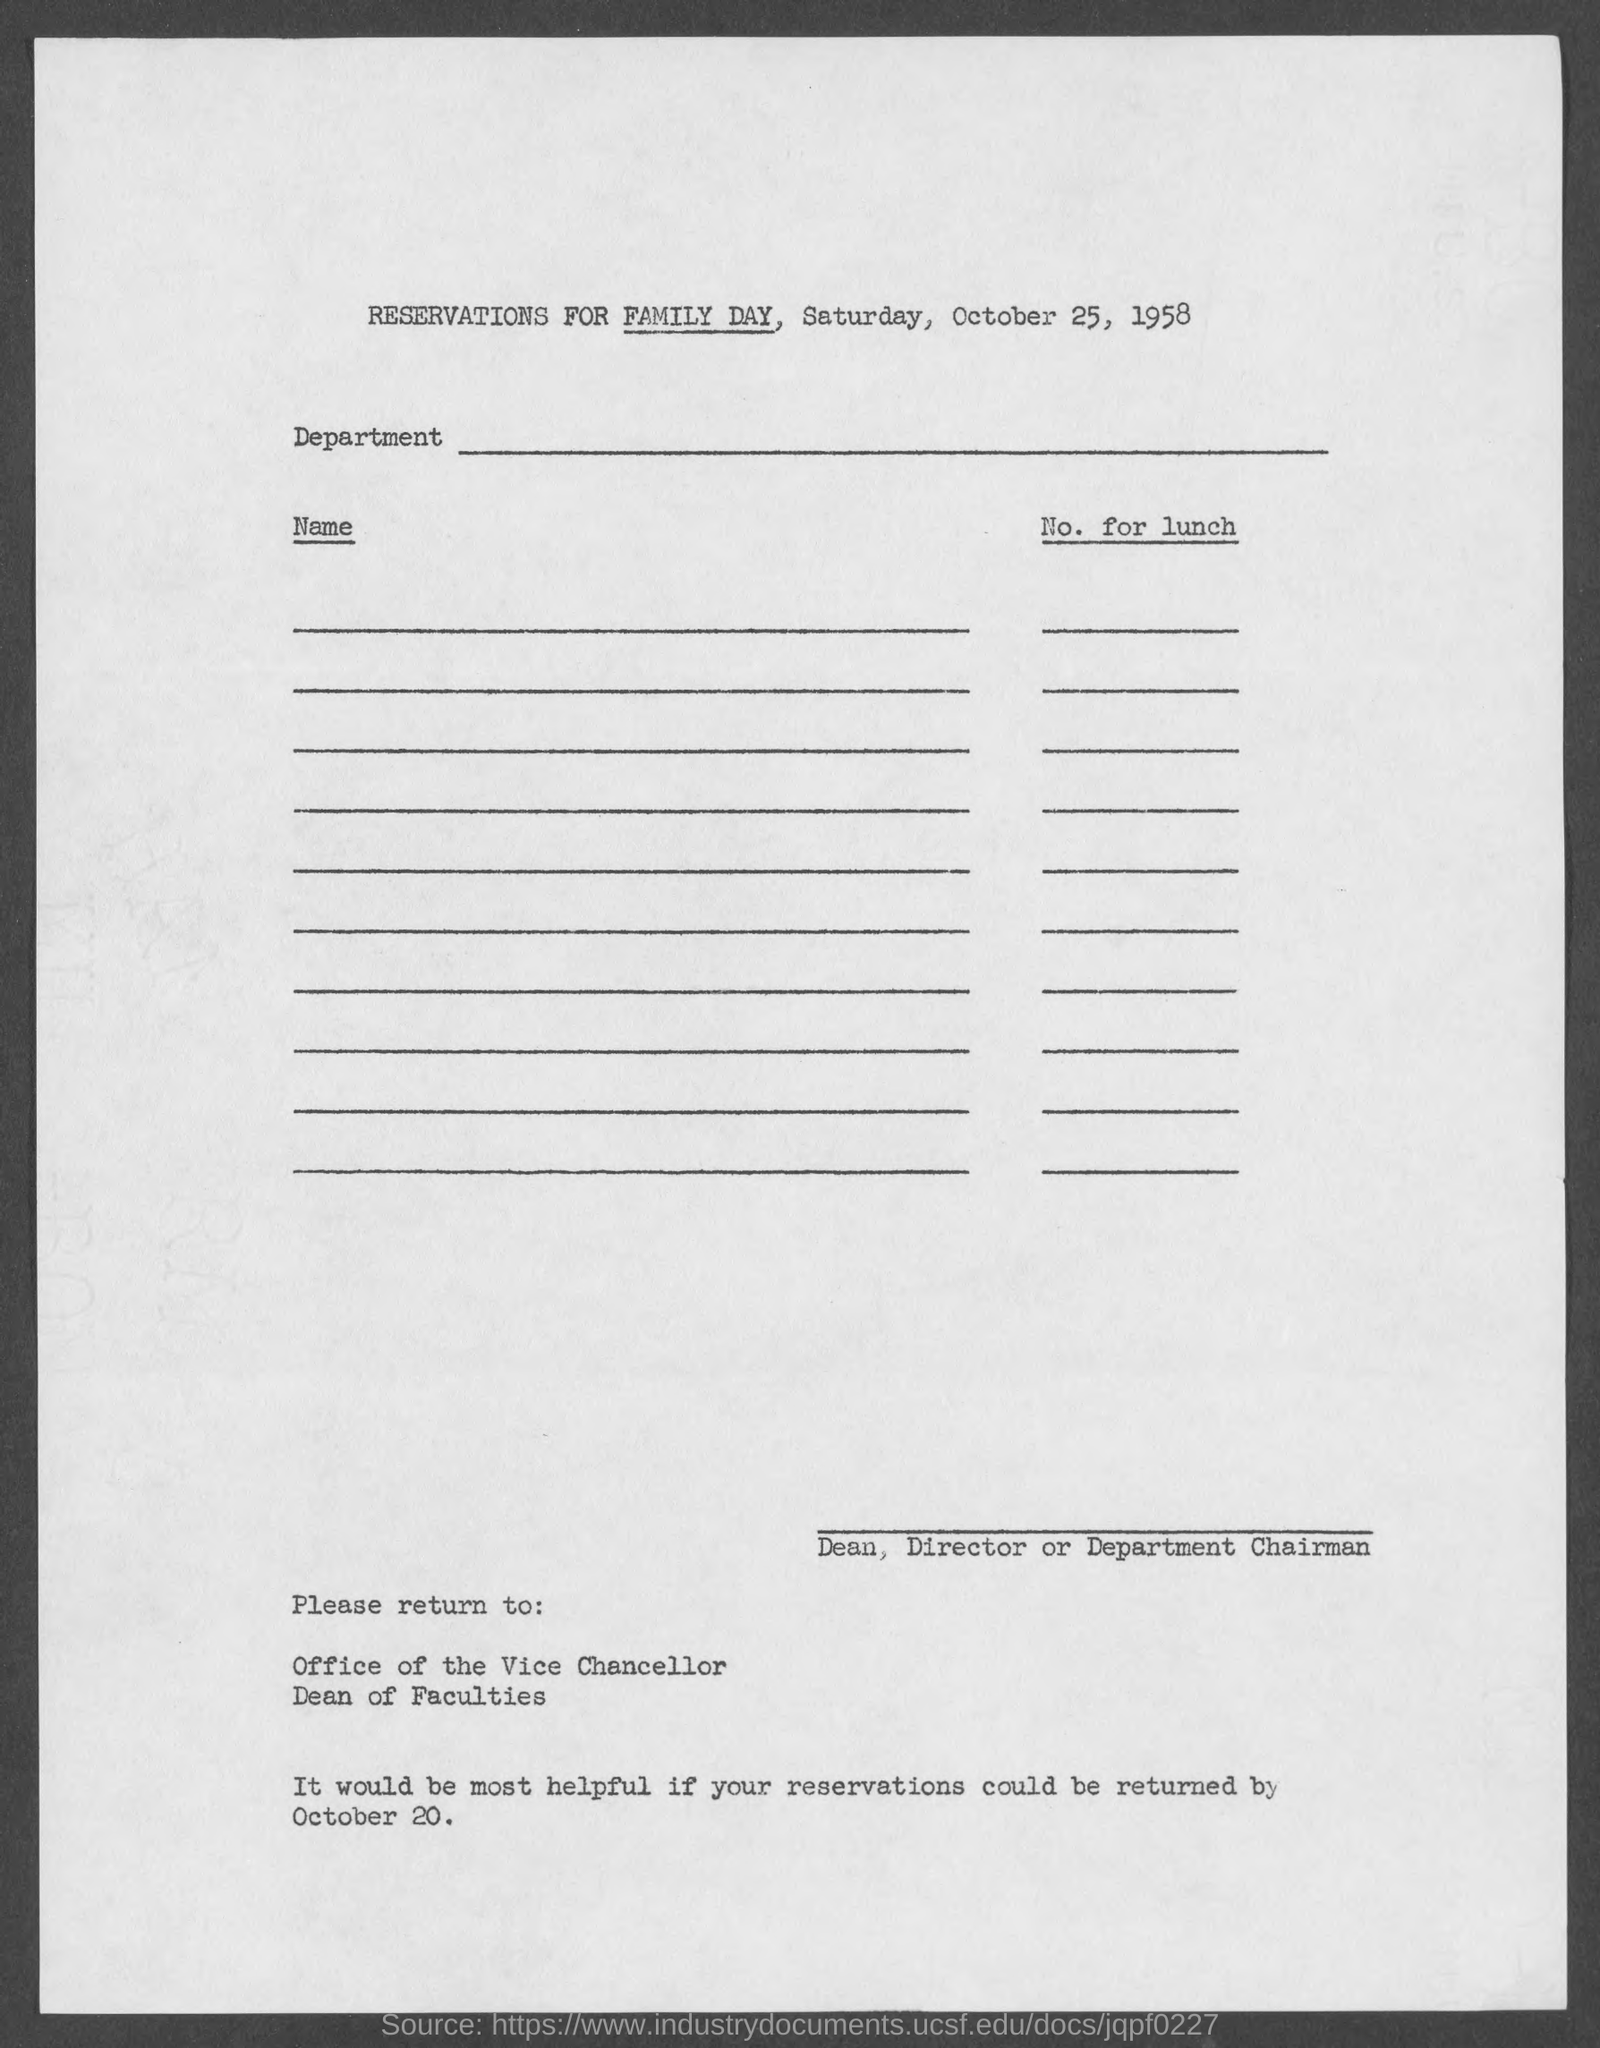Highlight a few significant elements in this photo. The last day to return the reservation form was October 20th. The title mentions a year, and the question asks which year that is. The year in question is 1958. The function mentioned in the reservation form is "FAMILY DAY. 